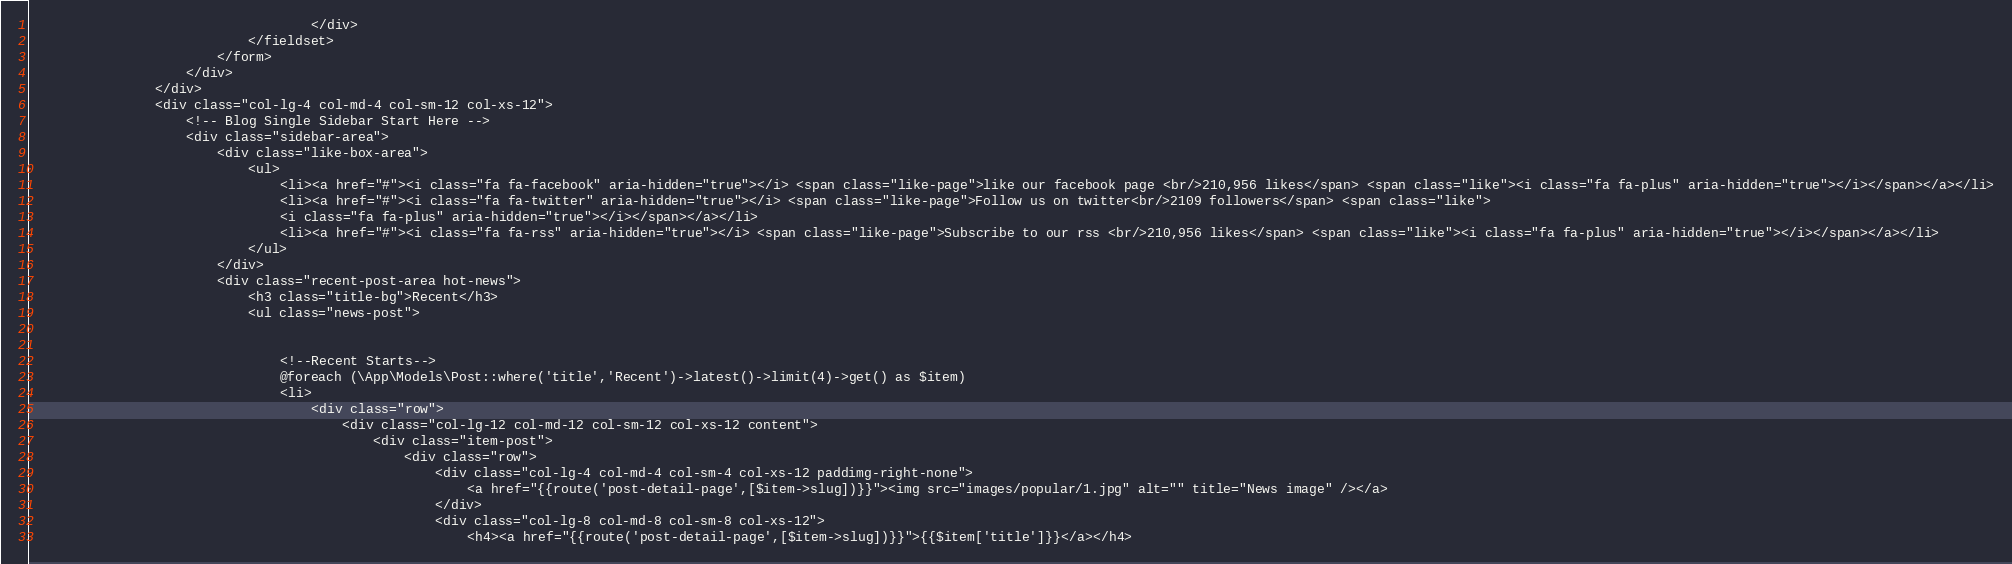<code> <loc_0><loc_0><loc_500><loc_500><_PHP_>                                    </div>
                            </fieldset>
                        </form>
                    </div>                                 
                </div>
                <div class="col-lg-4 col-md-4 col-sm-12 col-xs-12">
                    <!-- Blog Single Sidebar Start Here -->
                    <div class="sidebar-area">
                        <div class="like-box-area">
                            <ul>
                                <li><a href="#"><i class="fa fa-facebook" aria-hidden="true"></i> <span class="like-page">like our facebook page <br/>210,956 likes</span> <span class="like"><i class="fa fa-plus" aria-hidden="true"></i></span></a></li>
                                <li><a href="#"><i class="fa fa-twitter" aria-hidden="true"></i> <span class="like-page">Follow us on twitter<br/>2109 followers</span> <span class="like">
                                <i class="fa fa-plus" aria-hidden="true"></i></span></a></li>
                                <li><a href="#"><i class="fa fa-rss" aria-hidden="true"></i> <span class="like-page">Subscribe to our rss <br/>210,956 likes</span> <span class="like"><i class="fa fa-plus" aria-hidden="true"></i></span></a></li>
                            </ul>
                        </div>
                        <div class="recent-post-area hot-news">
                            <h3 class="title-bg">Recent</h3>
                            <ul class="news-post">
                                

                                <!--Recent Starts-->
                                @foreach (\App\Models\Post::where('title','Recent')->latest()->limit(4)->get() as $item)
                                <li>
                                    <div class="row">
                                        <div class="col-lg-12 col-md-12 col-sm-12 col-xs-12 content">
                                            <div class="item-post">
                                                <div class="row">
                                                    <div class="col-lg-4 col-md-4 col-sm-4 col-xs-12 paddimg-right-none">
                                                        <a href="{{route('post-detail-page',[$item->slug])}}"><img src="images/popular/1.jpg" alt="" title="News image" /></a>
                                                    </div>
                                                    <div class="col-lg-8 col-md-8 col-sm-8 col-xs-12">
                                                        <h4><a href="{{route('post-detail-page',[$item->slug])}}">{{$item['title']}}</a></h4></code> 